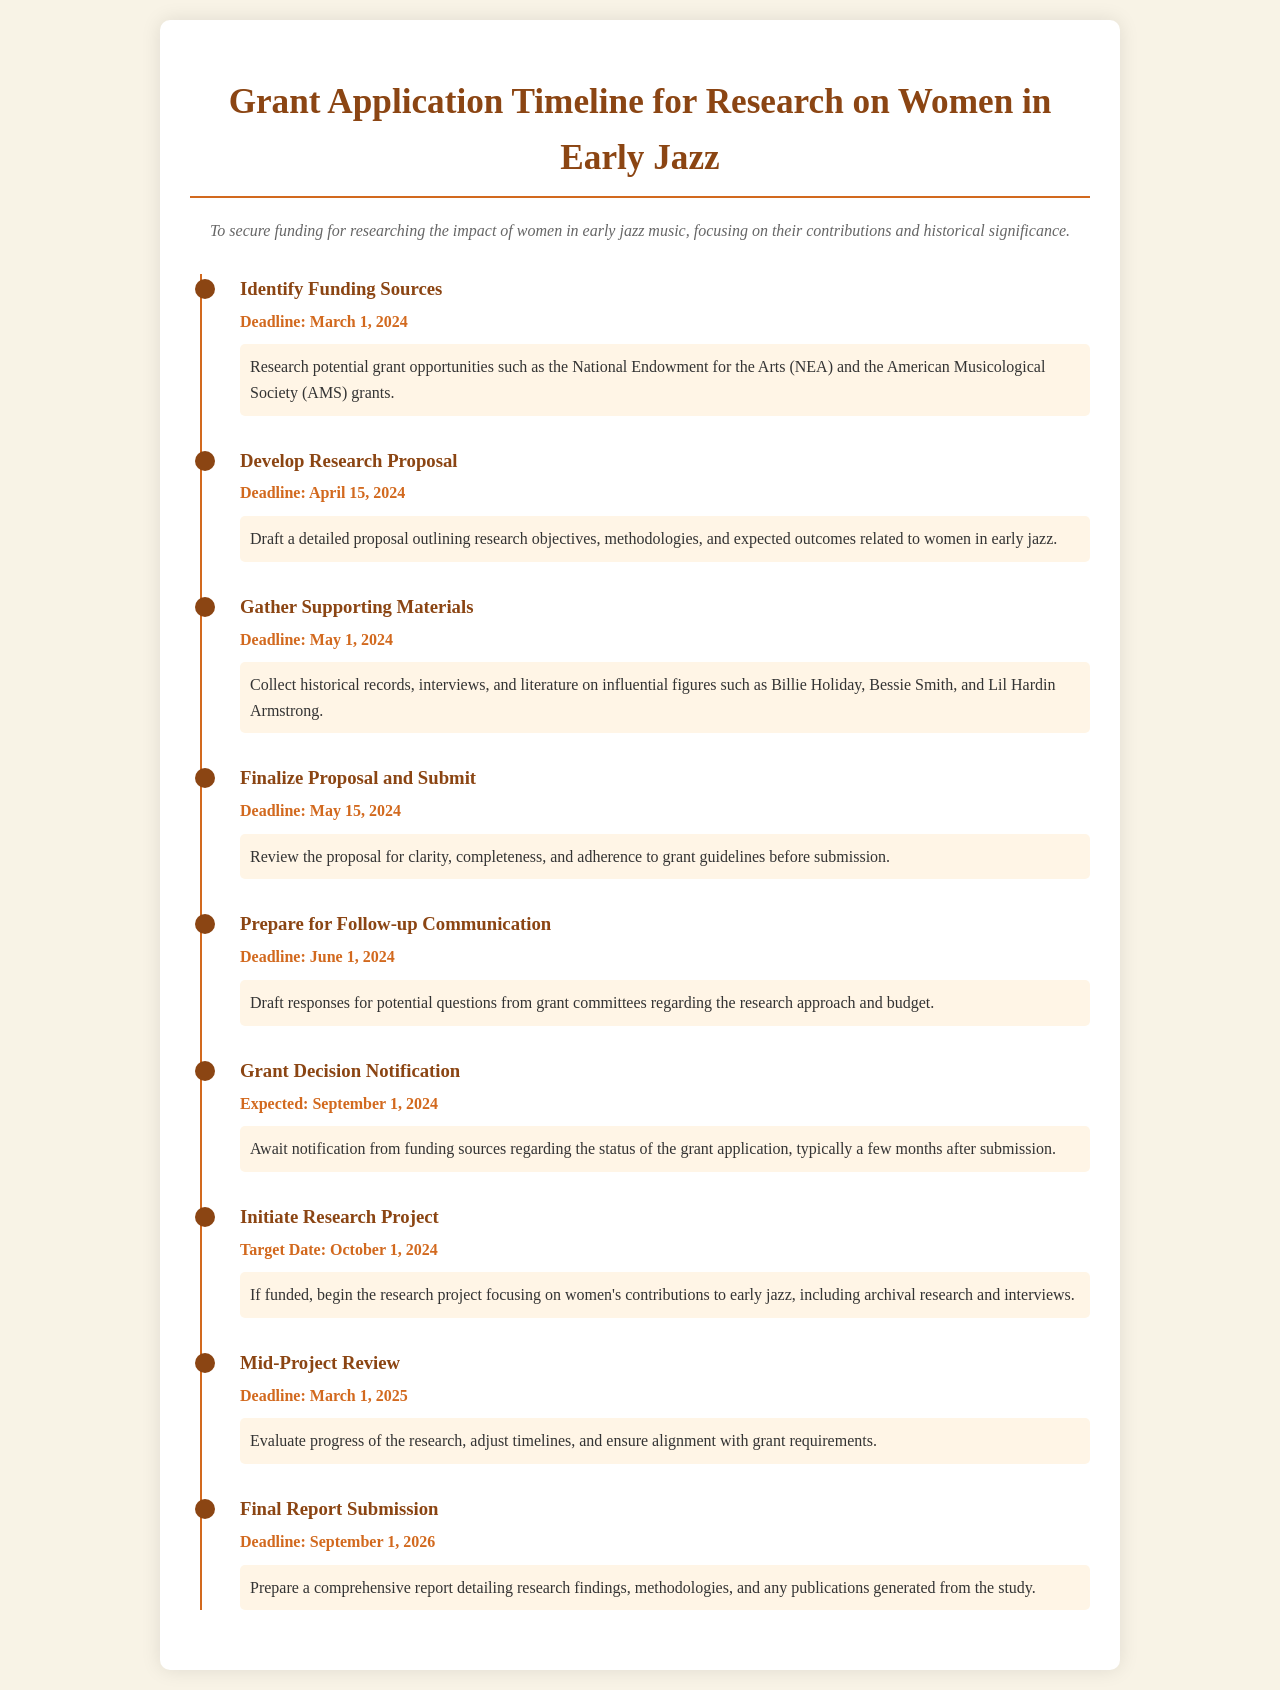What is the deadline for identifying funding sources? The deadline for identifying funding sources is clearly stated in the timeline under that milestone.
Answer: March 1, 2024 What is the target date for initiating the research project? The target date for initiating the research project is specified in the timeline as the intended start date.
Answer: October 1, 2024 What is the expected date for grant decision notification? The expected date for grant decision notification is mentioned under that milestone in the timeline.
Answer: September 1, 2024 How many days are there between gathering supporting materials and finalizing the proposal? By calculating the number of days between the two specified deadlines, you can find the duration.
Answer: 14 days What is the final report submission deadline? The final report submission deadline is provided in the timeline under that milestone.
Answer: September 1, 2026 What is the focus of the research proposal to be developed? The focus of the research proposal can be inferred by the subject matter stated in the timeline for developing the proposal.
Answer: Women in early jazz What materials need to be gathered to support the research? The types of materials to be gathered are outlined in the corresponding milestone in the timeline.
Answer: Historical records, interviews, literature What is the purpose of preparing for follow-up communication? The purpose can be summarized from the details provided in the milestone regarding communication preparation.
Answer: Responding to questions from grant committees 